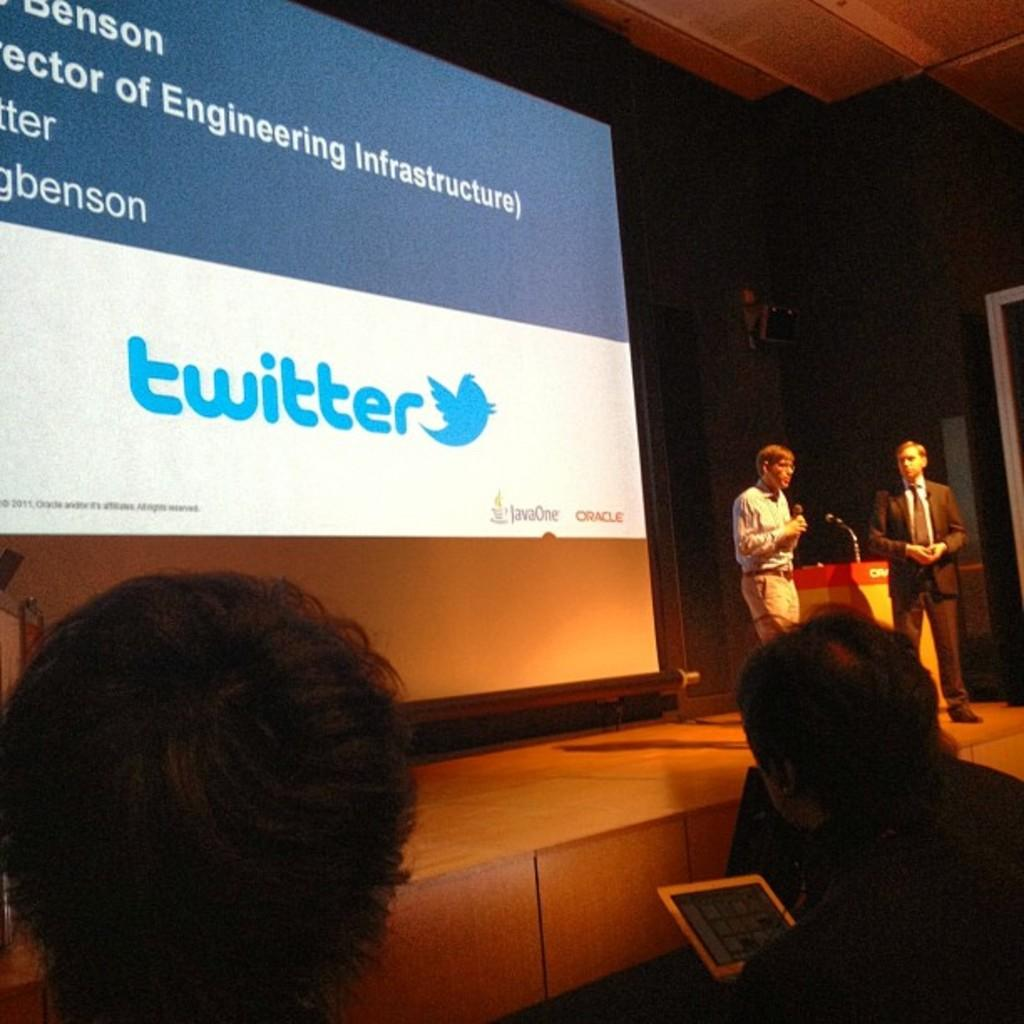What is the main object in the image? There is a screen in the image. What is displayed on the screen? There is writing on the screen. What can be seen in the background of the image? There is a wall in the image. What device is present for amplifying sound? There is a microphone (mic) in the image. Who is present in the image? There are people in the image. What electronic device is visible besides the screen? There is a tablet in the image. What color is the sock on the table in the image? There is no sock present in the image. What caused the writing on the screen to appear? The facts provided do not mention the cause of the writing on the screen. 